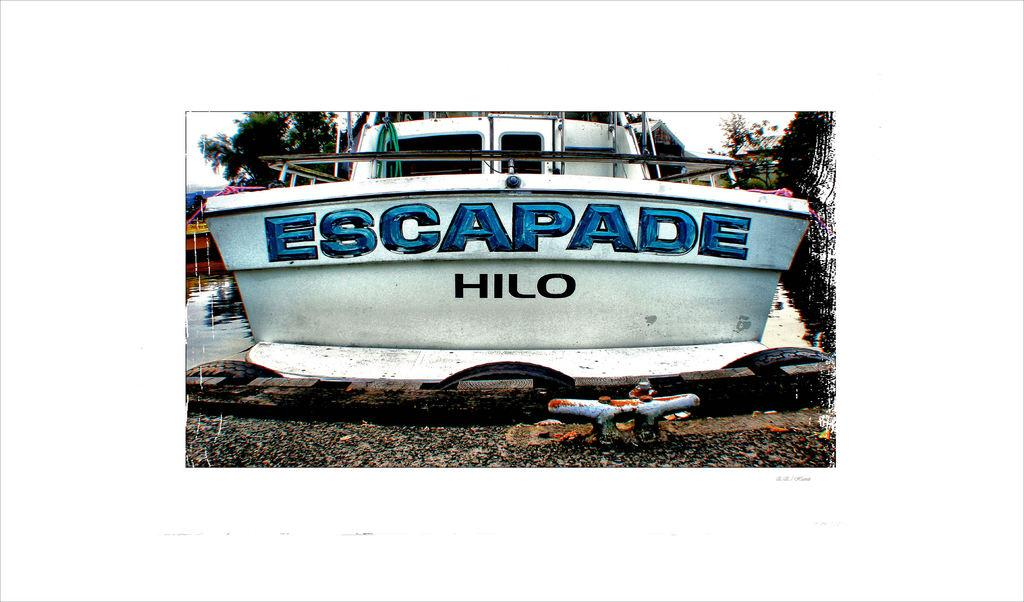<image>
Summarize the visual content of the image. A white boat that says Escapade in blue letters across the front. 